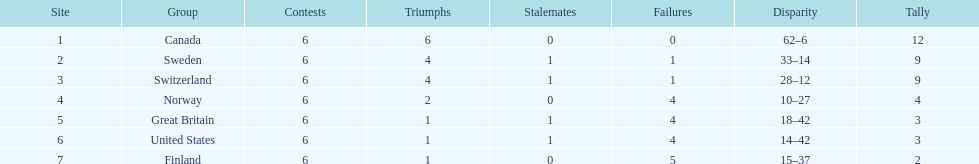Which country finished below the united states? Finland. 